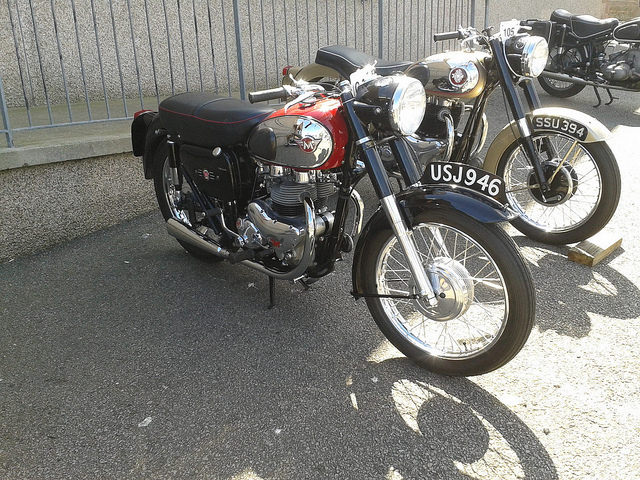Identify the text displayed in this image. USJ946 SSU394 105 